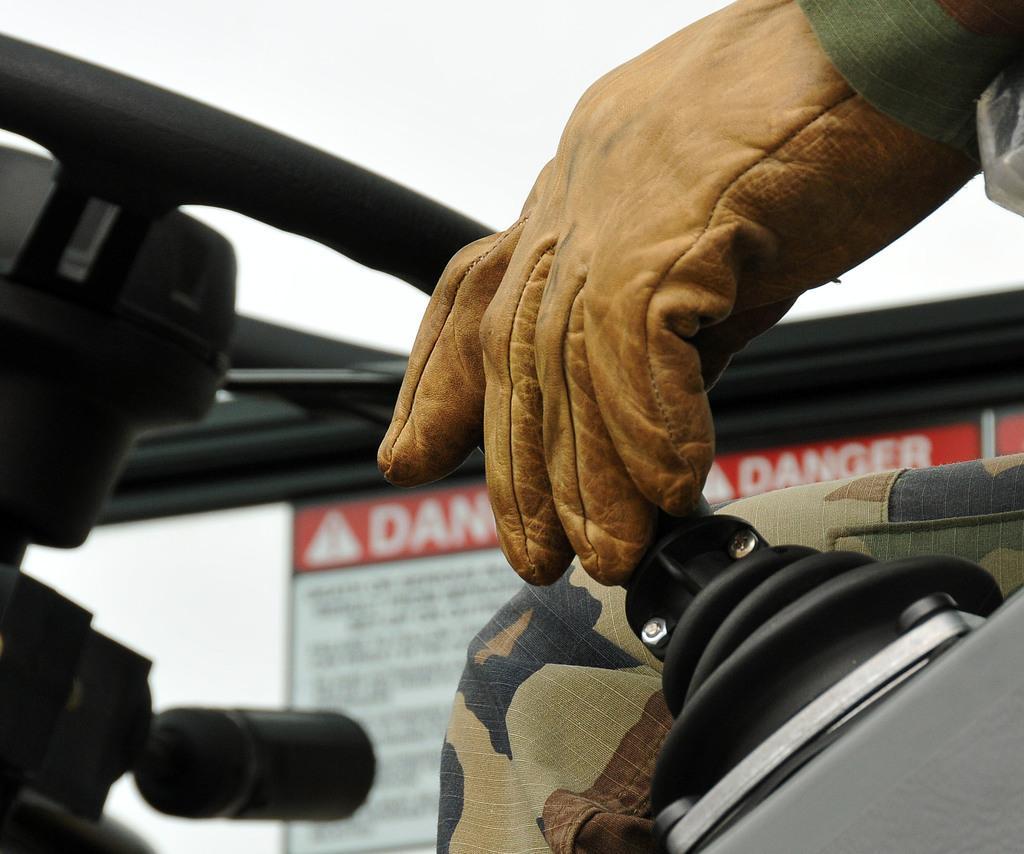Describe this image in one or two sentences. In this image there is a jeep in that jeep there is a man sitting, in the background there is a board, on that board there is some text. 